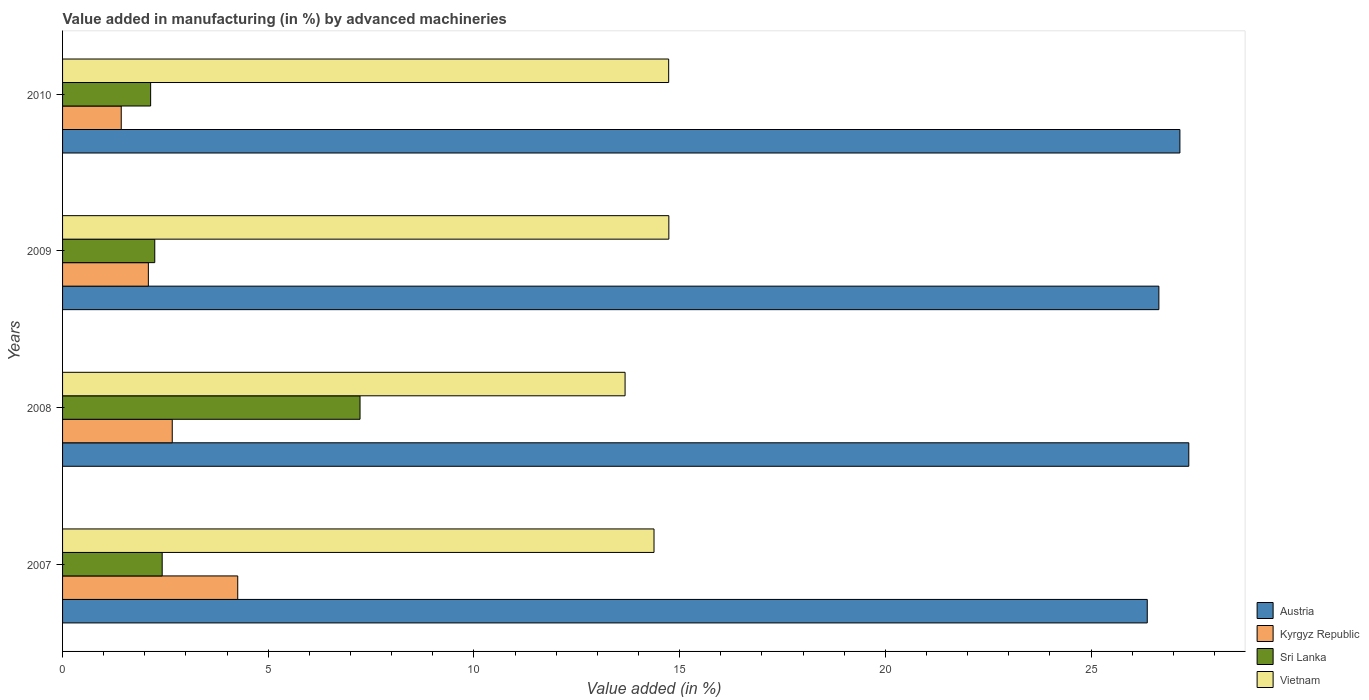How many different coloured bars are there?
Offer a terse response. 4. How many groups of bars are there?
Give a very brief answer. 4. Are the number of bars on each tick of the Y-axis equal?
Provide a succinct answer. Yes. What is the label of the 4th group of bars from the top?
Your answer should be very brief. 2007. In how many cases, is the number of bars for a given year not equal to the number of legend labels?
Provide a short and direct response. 0. What is the percentage of value added in manufacturing by advanced machineries in Austria in 2008?
Make the answer very short. 27.38. Across all years, what is the maximum percentage of value added in manufacturing by advanced machineries in Austria?
Your response must be concise. 27.38. Across all years, what is the minimum percentage of value added in manufacturing by advanced machineries in Austria?
Make the answer very short. 26.37. What is the total percentage of value added in manufacturing by advanced machineries in Vietnam in the graph?
Your answer should be compact. 57.52. What is the difference between the percentage of value added in manufacturing by advanced machineries in Austria in 2008 and that in 2009?
Your answer should be very brief. 0.73. What is the difference between the percentage of value added in manufacturing by advanced machineries in Vietnam in 2010 and the percentage of value added in manufacturing by advanced machineries in Sri Lanka in 2008?
Offer a very short reply. 7.5. What is the average percentage of value added in manufacturing by advanced machineries in Sri Lanka per year?
Ensure brevity in your answer.  3.51. In the year 2007, what is the difference between the percentage of value added in manufacturing by advanced machineries in Austria and percentage of value added in manufacturing by advanced machineries in Vietnam?
Give a very brief answer. 11.99. What is the ratio of the percentage of value added in manufacturing by advanced machineries in Kyrgyz Republic in 2007 to that in 2008?
Give a very brief answer. 1.6. Is the percentage of value added in manufacturing by advanced machineries in Sri Lanka in 2009 less than that in 2010?
Your response must be concise. No. What is the difference between the highest and the second highest percentage of value added in manufacturing by advanced machineries in Austria?
Offer a terse response. 0.22. What is the difference between the highest and the lowest percentage of value added in manufacturing by advanced machineries in Kyrgyz Republic?
Your answer should be compact. 2.83. In how many years, is the percentage of value added in manufacturing by advanced machineries in Vietnam greater than the average percentage of value added in manufacturing by advanced machineries in Vietnam taken over all years?
Give a very brief answer. 2. Is the sum of the percentage of value added in manufacturing by advanced machineries in Vietnam in 2007 and 2009 greater than the maximum percentage of value added in manufacturing by advanced machineries in Kyrgyz Republic across all years?
Give a very brief answer. Yes. What does the 3rd bar from the top in 2007 represents?
Your response must be concise. Kyrgyz Republic. What does the 4th bar from the bottom in 2007 represents?
Your answer should be compact. Vietnam. Is it the case that in every year, the sum of the percentage of value added in manufacturing by advanced machineries in Austria and percentage of value added in manufacturing by advanced machineries in Sri Lanka is greater than the percentage of value added in manufacturing by advanced machineries in Vietnam?
Ensure brevity in your answer.  Yes. How many years are there in the graph?
Ensure brevity in your answer.  4. Are the values on the major ticks of X-axis written in scientific E-notation?
Offer a terse response. No. What is the title of the graph?
Make the answer very short. Value added in manufacturing (in %) by advanced machineries. Does "St. Vincent and the Grenadines" appear as one of the legend labels in the graph?
Offer a terse response. No. What is the label or title of the X-axis?
Ensure brevity in your answer.  Value added (in %). What is the label or title of the Y-axis?
Provide a succinct answer. Years. What is the Value added (in %) in Austria in 2007?
Your answer should be compact. 26.37. What is the Value added (in %) of Kyrgyz Republic in 2007?
Your answer should be very brief. 4.26. What is the Value added (in %) in Sri Lanka in 2007?
Keep it short and to the point. 2.42. What is the Value added (in %) in Vietnam in 2007?
Offer a very short reply. 14.38. What is the Value added (in %) of Austria in 2008?
Provide a short and direct response. 27.38. What is the Value added (in %) of Kyrgyz Republic in 2008?
Offer a very short reply. 2.67. What is the Value added (in %) in Sri Lanka in 2008?
Your answer should be very brief. 7.23. What is the Value added (in %) in Vietnam in 2008?
Keep it short and to the point. 13.67. What is the Value added (in %) of Austria in 2009?
Keep it short and to the point. 26.65. What is the Value added (in %) in Kyrgyz Republic in 2009?
Offer a terse response. 2.09. What is the Value added (in %) of Sri Lanka in 2009?
Give a very brief answer. 2.24. What is the Value added (in %) in Vietnam in 2009?
Provide a short and direct response. 14.74. What is the Value added (in %) in Austria in 2010?
Make the answer very short. 27.16. What is the Value added (in %) in Kyrgyz Republic in 2010?
Offer a terse response. 1.43. What is the Value added (in %) in Sri Lanka in 2010?
Offer a very short reply. 2.14. What is the Value added (in %) in Vietnam in 2010?
Ensure brevity in your answer.  14.73. Across all years, what is the maximum Value added (in %) of Austria?
Offer a terse response. 27.38. Across all years, what is the maximum Value added (in %) of Kyrgyz Republic?
Your answer should be very brief. 4.26. Across all years, what is the maximum Value added (in %) in Sri Lanka?
Give a very brief answer. 7.23. Across all years, what is the maximum Value added (in %) in Vietnam?
Your answer should be very brief. 14.74. Across all years, what is the minimum Value added (in %) of Austria?
Your answer should be compact. 26.37. Across all years, what is the minimum Value added (in %) in Kyrgyz Republic?
Provide a short and direct response. 1.43. Across all years, what is the minimum Value added (in %) in Sri Lanka?
Offer a very short reply. 2.14. Across all years, what is the minimum Value added (in %) of Vietnam?
Provide a succinct answer. 13.67. What is the total Value added (in %) of Austria in the graph?
Your response must be concise. 107.55. What is the total Value added (in %) in Kyrgyz Republic in the graph?
Provide a succinct answer. 10.44. What is the total Value added (in %) in Sri Lanka in the graph?
Ensure brevity in your answer.  14.03. What is the total Value added (in %) in Vietnam in the graph?
Give a very brief answer. 57.52. What is the difference between the Value added (in %) of Austria in 2007 and that in 2008?
Make the answer very short. -1.01. What is the difference between the Value added (in %) of Kyrgyz Republic in 2007 and that in 2008?
Your answer should be very brief. 1.59. What is the difference between the Value added (in %) in Sri Lanka in 2007 and that in 2008?
Ensure brevity in your answer.  -4.81. What is the difference between the Value added (in %) in Vietnam in 2007 and that in 2008?
Make the answer very short. 0.7. What is the difference between the Value added (in %) in Austria in 2007 and that in 2009?
Keep it short and to the point. -0.28. What is the difference between the Value added (in %) in Kyrgyz Republic in 2007 and that in 2009?
Provide a succinct answer. 2.17. What is the difference between the Value added (in %) in Sri Lanka in 2007 and that in 2009?
Give a very brief answer. 0.18. What is the difference between the Value added (in %) in Vietnam in 2007 and that in 2009?
Make the answer very short. -0.36. What is the difference between the Value added (in %) in Austria in 2007 and that in 2010?
Provide a short and direct response. -0.79. What is the difference between the Value added (in %) in Kyrgyz Republic in 2007 and that in 2010?
Provide a short and direct response. 2.83. What is the difference between the Value added (in %) of Sri Lanka in 2007 and that in 2010?
Provide a succinct answer. 0.28. What is the difference between the Value added (in %) in Vietnam in 2007 and that in 2010?
Provide a succinct answer. -0.36. What is the difference between the Value added (in %) in Austria in 2008 and that in 2009?
Provide a short and direct response. 0.73. What is the difference between the Value added (in %) in Kyrgyz Republic in 2008 and that in 2009?
Keep it short and to the point. 0.58. What is the difference between the Value added (in %) of Sri Lanka in 2008 and that in 2009?
Your response must be concise. 4.99. What is the difference between the Value added (in %) of Vietnam in 2008 and that in 2009?
Give a very brief answer. -1.06. What is the difference between the Value added (in %) of Austria in 2008 and that in 2010?
Give a very brief answer. 0.22. What is the difference between the Value added (in %) in Kyrgyz Republic in 2008 and that in 2010?
Provide a short and direct response. 1.24. What is the difference between the Value added (in %) in Sri Lanka in 2008 and that in 2010?
Your answer should be compact. 5.09. What is the difference between the Value added (in %) of Vietnam in 2008 and that in 2010?
Keep it short and to the point. -1.06. What is the difference between the Value added (in %) of Austria in 2009 and that in 2010?
Ensure brevity in your answer.  -0.51. What is the difference between the Value added (in %) of Kyrgyz Republic in 2009 and that in 2010?
Provide a short and direct response. 0.66. What is the difference between the Value added (in %) of Sri Lanka in 2009 and that in 2010?
Keep it short and to the point. 0.1. What is the difference between the Value added (in %) of Vietnam in 2009 and that in 2010?
Keep it short and to the point. 0. What is the difference between the Value added (in %) of Austria in 2007 and the Value added (in %) of Kyrgyz Republic in 2008?
Offer a terse response. 23.7. What is the difference between the Value added (in %) in Austria in 2007 and the Value added (in %) in Sri Lanka in 2008?
Your response must be concise. 19.14. What is the difference between the Value added (in %) in Austria in 2007 and the Value added (in %) in Vietnam in 2008?
Keep it short and to the point. 12.69. What is the difference between the Value added (in %) in Kyrgyz Republic in 2007 and the Value added (in %) in Sri Lanka in 2008?
Give a very brief answer. -2.97. What is the difference between the Value added (in %) in Kyrgyz Republic in 2007 and the Value added (in %) in Vietnam in 2008?
Ensure brevity in your answer.  -9.42. What is the difference between the Value added (in %) in Sri Lanka in 2007 and the Value added (in %) in Vietnam in 2008?
Keep it short and to the point. -11.25. What is the difference between the Value added (in %) in Austria in 2007 and the Value added (in %) in Kyrgyz Republic in 2009?
Offer a very short reply. 24.28. What is the difference between the Value added (in %) of Austria in 2007 and the Value added (in %) of Sri Lanka in 2009?
Offer a terse response. 24.12. What is the difference between the Value added (in %) of Austria in 2007 and the Value added (in %) of Vietnam in 2009?
Offer a very short reply. 11.63. What is the difference between the Value added (in %) in Kyrgyz Republic in 2007 and the Value added (in %) in Sri Lanka in 2009?
Offer a terse response. 2.02. What is the difference between the Value added (in %) in Kyrgyz Republic in 2007 and the Value added (in %) in Vietnam in 2009?
Offer a terse response. -10.48. What is the difference between the Value added (in %) of Sri Lanka in 2007 and the Value added (in %) of Vietnam in 2009?
Offer a terse response. -12.32. What is the difference between the Value added (in %) in Austria in 2007 and the Value added (in %) in Kyrgyz Republic in 2010?
Give a very brief answer. 24.94. What is the difference between the Value added (in %) of Austria in 2007 and the Value added (in %) of Sri Lanka in 2010?
Give a very brief answer. 24.23. What is the difference between the Value added (in %) in Austria in 2007 and the Value added (in %) in Vietnam in 2010?
Make the answer very short. 11.63. What is the difference between the Value added (in %) in Kyrgyz Republic in 2007 and the Value added (in %) in Sri Lanka in 2010?
Offer a terse response. 2.12. What is the difference between the Value added (in %) of Kyrgyz Republic in 2007 and the Value added (in %) of Vietnam in 2010?
Ensure brevity in your answer.  -10.47. What is the difference between the Value added (in %) in Sri Lanka in 2007 and the Value added (in %) in Vietnam in 2010?
Give a very brief answer. -12.31. What is the difference between the Value added (in %) in Austria in 2008 and the Value added (in %) in Kyrgyz Republic in 2009?
Provide a short and direct response. 25.29. What is the difference between the Value added (in %) in Austria in 2008 and the Value added (in %) in Sri Lanka in 2009?
Make the answer very short. 25.13. What is the difference between the Value added (in %) of Austria in 2008 and the Value added (in %) of Vietnam in 2009?
Ensure brevity in your answer.  12.64. What is the difference between the Value added (in %) of Kyrgyz Republic in 2008 and the Value added (in %) of Sri Lanka in 2009?
Ensure brevity in your answer.  0.42. What is the difference between the Value added (in %) in Kyrgyz Republic in 2008 and the Value added (in %) in Vietnam in 2009?
Keep it short and to the point. -12.07. What is the difference between the Value added (in %) of Sri Lanka in 2008 and the Value added (in %) of Vietnam in 2009?
Offer a very short reply. -7.51. What is the difference between the Value added (in %) of Austria in 2008 and the Value added (in %) of Kyrgyz Republic in 2010?
Your answer should be very brief. 25.95. What is the difference between the Value added (in %) in Austria in 2008 and the Value added (in %) in Sri Lanka in 2010?
Offer a terse response. 25.23. What is the difference between the Value added (in %) of Austria in 2008 and the Value added (in %) of Vietnam in 2010?
Offer a very short reply. 12.64. What is the difference between the Value added (in %) of Kyrgyz Republic in 2008 and the Value added (in %) of Sri Lanka in 2010?
Ensure brevity in your answer.  0.53. What is the difference between the Value added (in %) of Kyrgyz Republic in 2008 and the Value added (in %) of Vietnam in 2010?
Offer a very short reply. -12.07. What is the difference between the Value added (in %) of Sri Lanka in 2008 and the Value added (in %) of Vietnam in 2010?
Provide a short and direct response. -7.5. What is the difference between the Value added (in %) in Austria in 2009 and the Value added (in %) in Kyrgyz Republic in 2010?
Offer a very short reply. 25.22. What is the difference between the Value added (in %) in Austria in 2009 and the Value added (in %) in Sri Lanka in 2010?
Your response must be concise. 24.51. What is the difference between the Value added (in %) in Austria in 2009 and the Value added (in %) in Vietnam in 2010?
Your answer should be very brief. 11.92. What is the difference between the Value added (in %) of Kyrgyz Republic in 2009 and the Value added (in %) of Sri Lanka in 2010?
Your response must be concise. -0.06. What is the difference between the Value added (in %) of Kyrgyz Republic in 2009 and the Value added (in %) of Vietnam in 2010?
Your response must be concise. -12.65. What is the difference between the Value added (in %) in Sri Lanka in 2009 and the Value added (in %) in Vietnam in 2010?
Provide a succinct answer. -12.49. What is the average Value added (in %) in Austria per year?
Make the answer very short. 26.89. What is the average Value added (in %) of Kyrgyz Republic per year?
Keep it short and to the point. 2.61. What is the average Value added (in %) in Sri Lanka per year?
Ensure brevity in your answer.  3.51. What is the average Value added (in %) in Vietnam per year?
Offer a very short reply. 14.38. In the year 2007, what is the difference between the Value added (in %) in Austria and Value added (in %) in Kyrgyz Republic?
Provide a succinct answer. 22.11. In the year 2007, what is the difference between the Value added (in %) in Austria and Value added (in %) in Sri Lanka?
Give a very brief answer. 23.94. In the year 2007, what is the difference between the Value added (in %) in Austria and Value added (in %) in Vietnam?
Make the answer very short. 11.99. In the year 2007, what is the difference between the Value added (in %) in Kyrgyz Republic and Value added (in %) in Sri Lanka?
Your answer should be compact. 1.84. In the year 2007, what is the difference between the Value added (in %) in Kyrgyz Republic and Value added (in %) in Vietnam?
Make the answer very short. -10.12. In the year 2007, what is the difference between the Value added (in %) in Sri Lanka and Value added (in %) in Vietnam?
Offer a very short reply. -11.96. In the year 2008, what is the difference between the Value added (in %) in Austria and Value added (in %) in Kyrgyz Republic?
Provide a short and direct response. 24.71. In the year 2008, what is the difference between the Value added (in %) in Austria and Value added (in %) in Sri Lanka?
Make the answer very short. 20.14. In the year 2008, what is the difference between the Value added (in %) of Austria and Value added (in %) of Vietnam?
Make the answer very short. 13.7. In the year 2008, what is the difference between the Value added (in %) of Kyrgyz Republic and Value added (in %) of Sri Lanka?
Give a very brief answer. -4.56. In the year 2008, what is the difference between the Value added (in %) of Kyrgyz Republic and Value added (in %) of Vietnam?
Offer a very short reply. -11.01. In the year 2008, what is the difference between the Value added (in %) of Sri Lanka and Value added (in %) of Vietnam?
Keep it short and to the point. -6.44. In the year 2009, what is the difference between the Value added (in %) of Austria and Value added (in %) of Kyrgyz Republic?
Give a very brief answer. 24.56. In the year 2009, what is the difference between the Value added (in %) in Austria and Value added (in %) in Sri Lanka?
Provide a succinct answer. 24.41. In the year 2009, what is the difference between the Value added (in %) in Austria and Value added (in %) in Vietnam?
Your answer should be very brief. 11.91. In the year 2009, what is the difference between the Value added (in %) in Kyrgyz Republic and Value added (in %) in Sri Lanka?
Provide a short and direct response. -0.16. In the year 2009, what is the difference between the Value added (in %) of Kyrgyz Republic and Value added (in %) of Vietnam?
Give a very brief answer. -12.65. In the year 2009, what is the difference between the Value added (in %) in Sri Lanka and Value added (in %) in Vietnam?
Your answer should be compact. -12.5. In the year 2010, what is the difference between the Value added (in %) of Austria and Value added (in %) of Kyrgyz Republic?
Ensure brevity in your answer.  25.73. In the year 2010, what is the difference between the Value added (in %) in Austria and Value added (in %) in Sri Lanka?
Offer a terse response. 25.02. In the year 2010, what is the difference between the Value added (in %) of Austria and Value added (in %) of Vietnam?
Provide a succinct answer. 12.43. In the year 2010, what is the difference between the Value added (in %) of Kyrgyz Republic and Value added (in %) of Sri Lanka?
Provide a short and direct response. -0.71. In the year 2010, what is the difference between the Value added (in %) of Kyrgyz Republic and Value added (in %) of Vietnam?
Your response must be concise. -13.31. In the year 2010, what is the difference between the Value added (in %) of Sri Lanka and Value added (in %) of Vietnam?
Provide a succinct answer. -12.59. What is the ratio of the Value added (in %) in Austria in 2007 to that in 2008?
Give a very brief answer. 0.96. What is the ratio of the Value added (in %) in Kyrgyz Republic in 2007 to that in 2008?
Offer a very short reply. 1.6. What is the ratio of the Value added (in %) in Sri Lanka in 2007 to that in 2008?
Provide a succinct answer. 0.33. What is the ratio of the Value added (in %) in Vietnam in 2007 to that in 2008?
Keep it short and to the point. 1.05. What is the ratio of the Value added (in %) of Kyrgyz Republic in 2007 to that in 2009?
Provide a short and direct response. 2.04. What is the ratio of the Value added (in %) of Sri Lanka in 2007 to that in 2009?
Make the answer very short. 1.08. What is the ratio of the Value added (in %) in Vietnam in 2007 to that in 2009?
Your answer should be compact. 0.98. What is the ratio of the Value added (in %) in Austria in 2007 to that in 2010?
Make the answer very short. 0.97. What is the ratio of the Value added (in %) of Kyrgyz Republic in 2007 to that in 2010?
Offer a terse response. 2.99. What is the ratio of the Value added (in %) in Sri Lanka in 2007 to that in 2010?
Give a very brief answer. 1.13. What is the ratio of the Value added (in %) of Vietnam in 2007 to that in 2010?
Your response must be concise. 0.98. What is the ratio of the Value added (in %) of Austria in 2008 to that in 2009?
Your answer should be compact. 1.03. What is the ratio of the Value added (in %) in Kyrgyz Republic in 2008 to that in 2009?
Provide a short and direct response. 1.28. What is the ratio of the Value added (in %) in Sri Lanka in 2008 to that in 2009?
Ensure brevity in your answer.  3.23. What is the ratio of the Value added (in %) of Vietnam in 2008 to that in 2009?
Make the answer very short. 0.93. What is the ratio of the Value added (in %) in Austria in 2008 to that in 2010?
Offer a terse response. 1.01. What is the ratio of the Value added (in %) in Kyrgyz Republic in 2008 to that in 2010?
Your answer should be compact. 1.87. What is the ratio of the Value added (in %) of Sri Lanka in 2008 to that in 2010?
Your answer should be compact. 3.38. What is the ratio of the Value added (in %) of Vietnam in 2008 to that in 2010?
Offer a very short reply. 0.93. What is the ratio of the Value added (in %) in Austria in 2009 to that in 2010?
Provide a short and direct response. 0.98. What is the ratio of the Value added (in %) in Kyrgyz Republic in 2009 to that in 2010?
Offer a terse response. 1.46. What is the ratio of the Value added (in %) in Sri Lanka in 2009 to that in 2010?
Provide a short and direct response. 1.05. What is the difference between the highest and the second highest Value added (in %) in Austria?
Ensure brevity in your answer.  0.22. What is the difference between the highest and the second highest Value added (in %) of Kyrgyz Republic?
Provide a succinct answer. 1.59. What is the difference between the highest and the second highest Value added (in %) of Sri Lanka?
Offer a very short reply. 4.81. What is the difference between the highest and the second highest Value added (in %) of Vietnam?
Give a very brief answer. 0. What is the difference between the highest and the lowest Value added (in %) in Austria?
Provide a short and direct response. 1.01. What is the difference between the highest and the lowest Value added (in %) of Kyrgyz Republic?
Provide a short and direct response. 2.83. What is the difference between the highest and the lowest Value added (in %) of Sri Lanka?
Provide a succinct answer. 5.09. What is the difference between the highest and the lowest Value added (in %) in Vietnam?
Your answer should be very brief. 1.06. 